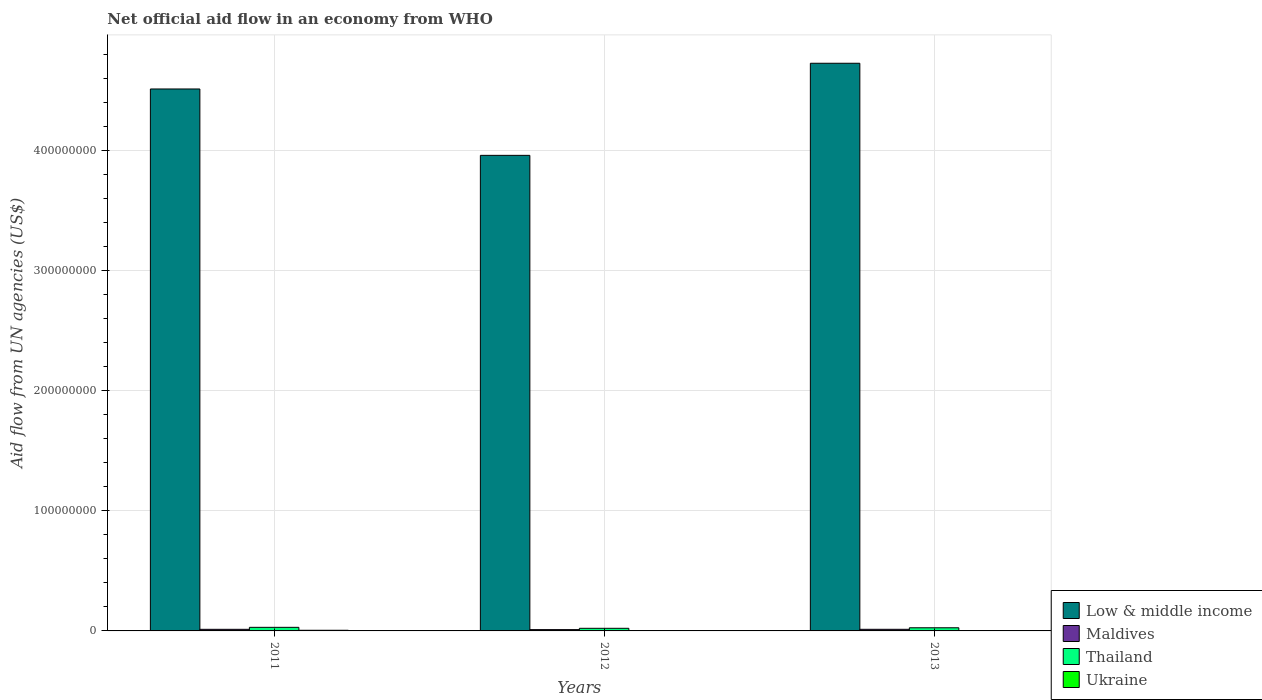How many different coloured bars are there?
Offer a very short reply. 4. In how many cases, is the number of bars for a given year not equal to the number of legend labels?
Offer a very short reply. 0. What is the net official aid flow in Ukraine in 2011?
Keep it short and to the point. 5.40e+05. Across all years, what is the maximum net official aid flow in Low & middle income?
Offer a very short reply. 4.73e+08. Across all years, what is the minimum net official aid flow in Thailand?
Provide a short and direct response. 2.18e+06. In which year was the net official aid flow in Thailand minimum?
Your answer should be compact. 2012. What is the total net official aid flow in Low & middle income in the graph?
Your answer should be compact. 1.32e+09. What is the difference between the net official aid flow in Thailand in 2012 and that in 2013?
Your answer should be compact. -4.40e+05. What is the difference between the net official aid flow in Maldives in 2011 and the net official aid flow in Low & middle income in 2012?
Your response must be concise. -3.95e+08. What is the average net official aid flow in Thailand per year?
Give a very brief answer. 2.60e+06. In the year 2013, what is the difference between the net official aid flow in Ukraine and net official aid flow in Maldives?
Keep it short and to the point. -1.19e+06. What is the ratio of the net official aid flow in Thailand in 2012 to that in 2013?
Your answer should be compact. 0.83. What is the difference between the highest and the lowest net official aid flow in Ukraine?
Your answer should be compact. 5.10e+05. In how many years, is the net official aid flow in Low & middle income greater than the average net official aid flow in Low & middle income taken over all years?
Your response must be concise. 2. Is the sum of the net official aid flow in Maldives in 2011 and 2013 greater than the maximum net official aid flow in Ukraine across all years?
Provide a succinct answer. Yes. What does the 3rd bar from the left in 2013 represents?
Provide a short and direct response. Thailand. What does the 3rd bar from the right in 2012 represents?
Your answer should be very brief. Maldives. Are all the bars in the graph horizontal?
Keep it short and to the point. No. How many legend labels are there?
Offer a very short reply. 4. How are the legend labels stacked?
Provide a succinct answer. Vertical. What is the title of the graph?
Provide a short and direct response. Net official aid flow in an economy from WHO. What is the label or title of the X-axis?
Give a very brief answer. Years. What is the label or title of the Y-axis?
Offer a terse response. Aid flow from UN agencies (US$). What is the Aid flow from UN agencies (US$) in Low & middle income in 2011?
Keep it short and to the point. 4.52e+08. What is the Aid flow from UN agencies (US$) of Maldives in 2011?
Your answer should be very brief. 1.34e+06. What is the Aid flow from UN agencies (US$) of Thailand in 2011?
Your answer should be compact. 2.99e+06. What is the Aid flow from UN agencies (US$) of Ukraine in 2011?
Provide a succinct answer. 5.40e+05. What is the Aid flow from UN agencies (US$) of Low & middle income in 2012?
Provide a short and direct response. 3.96e+08. What is the Aid flow from UN agencies (US$) in Maldives in 2012?
Your answer should be very brief. 1.09e+06. What is the Aid flow from UN agencies (US$) in Thailand in 2012?
Ensure brevity in your answer.  2.18e+06. What is the Aid flow from UN agencies (US$) in Low & middle income in 2013?
Provide a succinct answer. 4.73e+08. What is the Aid flow from UN agencies (US$) in Maldives in 2013?
Ensure brevity in your answer.  1.35e+06. What is the Aid flow from UN agencies (US$) of Thailand in 2013?
Make the answer very short. 2.62e+06. Across all years, what is the maximum Aid flow from UN agencies (US$) of Low & middle income?
Offer a terse response. 4.73e+08. Across all years, what is the maximum Aid flow from UN agencies (US$) in Maldives?
Ensure brevity in your answer.  1.35e+06. Across all years, what is the maximum Aid flow from UN agencies (US$) of Thailand?
Your answer should be very brief. 2.99e+06. Across all years, what is the maximum Aid flow from UN agencies (US$) of Ukraine?
Offer a terse response. 5.40e+05. Across all years, what is the minimum Aid flow from UN agencies (US$) of Low & middle income?
Make the answer very short. 3.96e+08. Across all years, what is the minimum Aid flow from UN agencies (US$) in Maldives?
Provide a short and direct response. 1.09e+06. Across all years, what is the minimum Aid flow from UN agencies (US$) in Thailand?
Keep it short and to the point. 2.18e+06. What is the total Aid flow from UN agencies (US$) in Low & middle income in the graph?
Ensure brevity in your answer.  1.32e+09. What is the total Aid flow from UN agencies (US$) in Maldives in the graph?
Your response must be concise. 3.78e+06. What is the total Aid flow from UN agencies (US$) in Thailand in the graph?
Provide a succinct answer. 7.79e+06. What is the total Aid flow from UN agencies (US$) of Ukraine in the graph?
Provide a succinct answer. 7.30e+05. What is the difference between the Aid flow from UN agencies (US$) in Low & middle income in 2011 and that in 2012?
Provide a succinct answer. 5.53e+07. What is the difference between the Aid flow from UN agencies (US$) of Thailand in 2011 and that in 2012?
Your answer should be compact. 8.10e+05. What is the difference between the Aid flow from UN agencies (US$) of Ukraine in 2011 and that in 2012?
Give a very brief answer. 5.10e+05. What is the difference between the Aid flow from UN agencies (US$) in Low & middle income in 2011 and that in 2013?
Provide a succinct answer. -2.14e+07. What is the difference between the Aid flow from UN agencies (US$) of Thailand in 2011 and that in 2013?
Your answer should be very brief. 3.70e+05. What is the difference between the Aid flow from UN agencies (US$) of Low & middle income in 2012 and that in 2013?
Your answer should be very brief. -7.67e+07. What is the difference between the Aid flow from UN agencies (US$) in Maldives in 2012 and that in 2013?
Offer a terse response. -2.60e+05. What is the difference between the Aid flow from UN agencies (US$) of Thailand in 2012 and that in 2013?
Your response must be concise. -4.40e+05. What is the difference between the Aid flow from UN agencies (US$) in Ukraine in 2012 and that in 2013?
Your response must be concise. -1.30e+05. What is the difference between the Aid flow from UN agencies (US$) of Low & middle income in 2011 and the Aid flow from UN agencies (US$) of Maldives in 2012?
Make the answer very short. 4.50e+08. What is the difference between the Aid flow from UN agencies (US$) in Low & middle income in 2011 and the Aid flow from UN agencies (US$) in Thailand in 2012?
Give a very brief answer. 4.49e+08. What is the difference between the Aid flow from UN agencies (US$) in Low & middle income in 2011 and the Aid flow from UN agencies (US$) in Ukraine in 2012?
Provide a short and direct response. 4.52e+08. What is the difference between the Aid flow from UN agencies (US$) in Maldives in 2011 and the Aid flow from UN agencies (US$) in Thailand in 2012?
Your answer should be very brief. -8.40e+05. What is the difference between the Aid flow from UN agencies (US$) in Maldives in 2011 and the Aid flow from UN agencies (US$) in Ukraine in 2012?
Your answer should be very brief. 1.31e+06. What is the difference between the Aid flow from UN agencies (US$) in Thailand in 2011 and the Aid flow from UN agencies (US$) in Ukraine in 2012?
Provide a succinct answer. 2.96e+06. What is the difference between the Aid flow from UN agencies (US$) in Low & middle income in 2011 and the Aid flow from UN agencies (US$) in Maldives in 2013?
Offer a very short reply. 4.50e+08. What is the difference between the Aid flow from UN agencies (US$) of Low & middle income in 2011 and the Aid flow from UN agencies (US$) of Thailand in 2013?
Offer a very short reply. 4.49e+08. What is the difference between the Aid flow from UN agencies (US$) in Low & middle income in 2011 and the Aid flow from UN agencies (US$) in Ukraine in 2013?
Provide a succinct answer. 4.51e+08. What is the difference between the Aid flow from UN agencies (US$) of Maldives in 2011 and the Aid flow from UN agencies (US$) of Thailand in 2013?
Ensure brevity in your answer.  -1.28e+06. What is the difference between the Aid flow from UN agencies (US$) in Maldives in 2011 and the Aid flow from UN agencies (US$) in Ukraine in 2013?
Offer a very short reply. 1.18e+06. What is the difference between the Aid flow from UN agencies (US$) of Thailand in 2011 and the Aid flow from UN agencies (US$) of Ukraine in 2013?
Ensure brevity in your answer.  2.83e+06. What is the difference between the Aid flow from UN agencies (US$) of Low & middle income in 2012 and the Aid flow from UN agencies (US$) of Maldives in 2013?
Your answer should be compact. 3.95e+08. What is the difference between the Aid flow from UN agencies (US$) in Low & middle income in 2012 and the Aid flow from UN agencies (US$) in Thailand in 2013?
Provide a succinct answer. 3.94e+08. What is the difference between the Aid flow from UN agencies (US$) in Low & middle income in 2012 and the Aid flow from UN agencies (US$) in Ukraine in 2013?
Offer a terse response. 3.96e+08. What is the difference between the Aid flow from UN agencies (US$) of Maldives in 2012 and the Aid flow from UN agencies (US$) of Thailand in 2013?
Provide a short and direct response. -1.53e+06. What is the difference between the Aid flow from UN agencies (US$) of Maldives in 2012 and the Aid flow from UN agencies (US$) of Ukraine in 2013?
Provide a short and direct response. 9.30e+05. What is the difference between the Aid flow from UN agencies (US$) of Thailand in 2012 and the Aid flow from UN agencies (US$) of Ukraine in 2013?
Your answer should be very brief. 2.02e+06. What is the average Aid flow from UN agencies (US$) of Low & middle income per year?
Make the answer very short. 4.40e+08. What is the average Aid flow from UN agencies (US$) of Maldives per year?
Offer a terse response. 1.26e+06. What is the average Aid flow from UN agencies (US$) in Thailand per year?
Give a very brief answer. 2.60e+06. What is the average Aid flow from UN agencies (US$) of Ukraine per year?
Offer a very short reply. 2.43e+05. In the year 2011, what is the difference between the Aid flow from UN agencies (US$) of Low & middle income and Aid flow from UN agencies (US$) of Maldives?
Your answer should be very brief. 4.50e+08. In the year 2011, what is the difference between the Aid flow from UN agencies (US$) of Low & middle income and Aid flow from UN agencies (US$) of Thailand?
Give a very brief answer. 4.49e+08. In the year 2011, what is the difference between the Aid flow from UN agencies (US$) of Low & middle income and Aid flow from UN agencies (US$) of Ukraine?
Give a very brief answer. 4.51e+08. In the year 2011, what is the difference between the Aid flow from UN agencies (US$) of Maldives and Aid flow from UN agencies (US$) of Thailand?
Your answer should be compact. -1.65e+06. In the year 2011, what is the difference between the Aid flow from UN agencies (US$) in Maldives and Aid flow from UN agencies (US$) in Ukraine?
Offer a very short reply. 8.00e+05. In the year 2011, what is the difference between the Aid flow from UN agencies (US$) in Thailand and Aid flow from UN agencies (US$) in Ukraine?
Keep it short and to the point. 2.45e+06. In the year 2012, what is the difference between the Aid flow from UN agencies (US$) of Low & middle income and Aid flow from UN agencies (US$) of Maldives?
Give a very brief answer. 3.95e+08. In the year 2012, what is the difference between the Aid flow from UN agencies (US$) of Low & middle income and Aid flow from UN agencies (US$) of Thailand?
Your answer should be compact. 3.94e+08. In the year 2012, what is the difference between the Aid flow from UN agencies (US$) of Low & middle income and Aid flow from UN agencies (US$) of Ukraine?
Give a very brief answer. 3.96e+08. In the year 2012, what is the difference between the Aid flow from UN agencies (US$) in Maldives and Aid flow from UN agencies (US$) in Thailand?
Offer a very short reply. -1.09e+06. In the year 2012, what is the difference between the Aid flow from UN agencies (US$) in Maldives and Aid flow from UN agencies (US$) in Ukraine?
Provide a short and direct response. 1.06e+06. In the year 2012, what is the difference between the Aid flow from UN agencies (US$) in Thailand and Aid flow from UN agencies (US$) in Ukraine?
Your response must be concise. 2.15e+06. In the year 2013, what is the difference between the Aid flow from UN agencies (US$) in Low & middle income and Aid flow from UN agencies (US$) in Maldives?
Offer a very short reply. 4.72e+08. In the year 2013, what is the difference between the Aid flow from UN agencies (US$) of Low & middle income and Aid flow from UN agencies (US$) of Thailand?
Your response must be concise. 4.70e+08. In the year 2013, what is the difference between the Aid flow from UN agencies (US$) in Low & middle income and Aid flow from UN agencies (US$) in Ukraine?
Make the answer very short. 4.73e+08. In the year 2013, what is the difference between the Aid flow from UN agencies (US$) in Maldives and Aid flow from UN agencies (US$) in Thailand?
Make the answer very short. -1.27e+06. In the year 2013, what is the difference between the Aid flow from UN agencies (US$) in Maldives and Aid flow from UN agencies (US$) in Ukraine?
Give a very brief answer. 1.19e+06. In the year 2013, what is the difference between the Aid flow from UN agencies (US$) of Thailand and Aid flow from UN agencies (US$) of Ukraine?
Provide a short and direct response. 2.46e+06. What is the ratio of the Aid flow from UN agencies (US$) in Low & middle income in 2011 to that in 2012?
Your response must be concise. 1.14. What is the ratio of the Aid flow from UN agencies (US$) in Maldives in 2011 to that in 2012?
Your answer should be very brief. 1.23. What is the ratio of the Aid flow from UN agencies (US$) in Thailand in 2011 to that in 2012?
Keep it short and to the point. 1.37. What is the ratio of the Aid flow from UN agencies (US$) of Low & middle income in 2011 to that in 2013?
Keep it short and to the point. 0.95. What is the ratio of the Aid flow from UN agencies (US$) of Maldives in 2011 to that in 2013?
Your answer should be compact. 0.99. What is the ratio of the Aid flow from UN agencies (US$) of Thailand in 2011 to that in 2013?
Ensure brevity in your answer.  1.14. What is the ratio of the Aid flow from UN agencies (US$) in Ukraine in 2011 to that in 2013?
Keep it short and to the point. 3.38. What is the ratio of the Aid flow from UN agencies (US$) in Low & middle income in 2012 to that in 2013?
Provide a short and direct response. 0.84. What is the ratio of the Aid flow from UN agencies (US$) in Maldives in 2012 to that in 2013?
Keep it short and to the point. 0.81. What is the ratio of the Aid flow from UN agencies (US$) in Thailand in 2012 to that in 2013?
Offer a terse response. 0.83. What is the ratio of the Aid flow from UN agencies (US$) in Ukraine in 2012 to that in 2013?
Give a very brief answer. 0.19. What is the difference between the highest and the second highest Aid flow from UN agencies (US$) of Low & middle income?
Your response must be concise. 2.14e+07. What is the difference between the highest and the second highest Aid flow from UN agencies (US$) of Maldives?
Provide a short and direct response. 10000. What is the difference between the highest and the second highest Aid flow from UN agencies (US$) of Ukraine?
Make the answer very short. 3.80e+05. What is the difference between the highest and the lowest Aid flow from UN agencies (US$) in Low & middle income?
Ensure brevity in your answer.  7.67e+07. What is the difference between the highest and the lowest Aid flow from UN agencies (US$) in Thailand?
Provide a succinct answer. 8.10e+05. What is the difference between the highest and the lowest Aid flow from UN agencies (US$) in Ukraine?
Make the answer very short. 5.10e+05. 